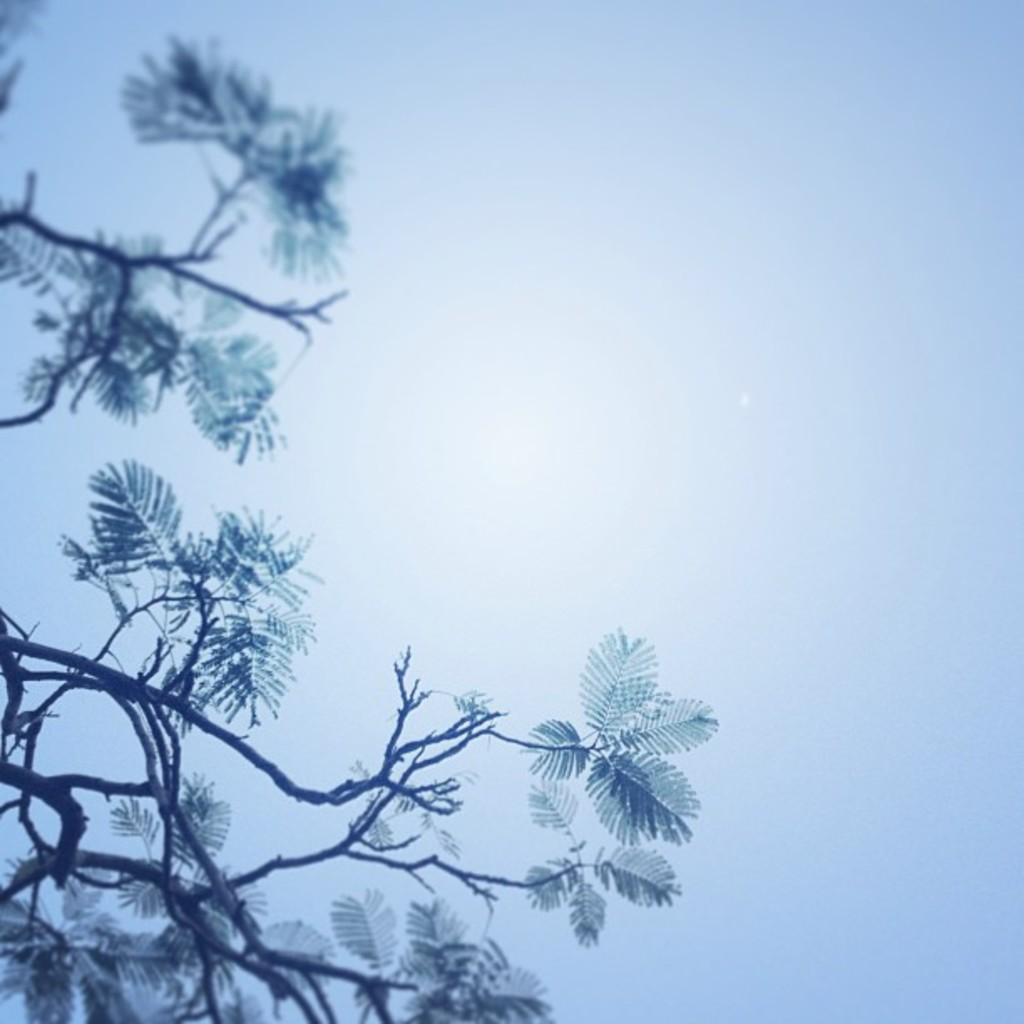What type of vegetation can be seen in the image? There are leaves and branches in the image. What is visible in the background of the image? The sky is visible in the background of the image. What type of sock is hanging from the roof in the image? There is no sock or roof present in the image; it features leaves and branches with the sky visible in the background. 